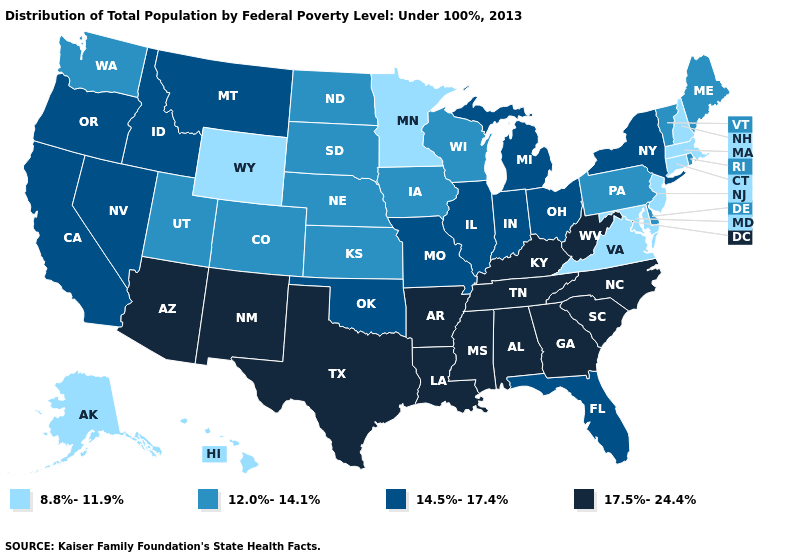Name the states that have a value in the range 17.5%-24.4%?
Give a very brief answer. Alabama, Arizona, Arkansas, Georgia, Kentucky, Louisiana, Mississippi, New Mexico, North Carolina, South Carolina, Tennessee, Texas, West Virginia. Name the states that have a value in the range 17.5%-24.4%?
Give a very brief answer. Alabama, Arizona, Arkansas, Georgia, Kentucky, Louisiana, Mississippi, New Mexico, North Carolina, South Carolina, Tennessee, Texas, West Virginia. What is the value of Iowa?
Short answer required. 12.0%-14.1%. What is the value of Wisconsin?
Write a very short answer. 12.0%-14.1%. Does Minnesota have the lowest value in the MidWest?
Short answer required. Yes. Does Indiana have the lowest value in the MidWest?
Short answer required. No. Name the states that have a value in the range 17.5%-24.4%?
Give a very brief answer. Alabama, Arizona, Arkansas, Georgia, Kentucky, Louisiana, Mississippi, New Mexico, North Carolina, South Carolina, Tennessee, Texas, West Virginia. Which states have the lowest value in the West?
Give a very brief answer. Alaska, Hawaii, Wyoming. Name the states that have a value in the range 14.5%-17.4%?
Quick response, please. California, Florida, Idaho, Illinois, Indiana, Michigan, Missouri, Montana, Nevada, New York, Ohio, Oklahoma, Oregon. Does the first symbol in the legend represent the smallest category?
Keep it brief. Yes. Does Georgia have the lowest value in the USA?
Answer briefly. No. Does Ohio have the highest value in the MidWest?
Concise answer only. Yes. Among the states that border Texas , does Oklahoma have the highest value?
Keep it brief. No. What is the lowest value in the MidWest?
Keep it brief. 8.8%-11.9%. Name the states that have a value in the range 14.5%-17.4%?
Quick response, please. California, Florida, Idaho, Illinois, Indiana, Michigan, Missouri, Montana, Nevada, New York, Ohio, Oklahoma, Oregon. 